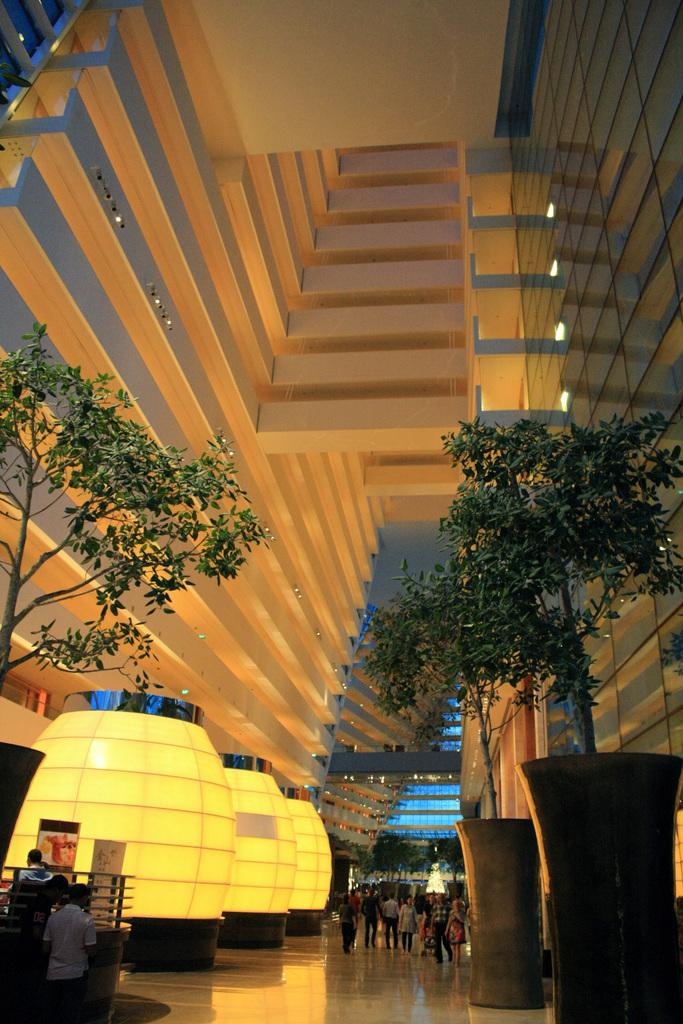What type of location is depicted in the image? The image shows an inside view of a building. Are there any people present in the image? Yes, there are people in the image. What can be seen in the background of the image? There are trees in the image. What additional decorations or features are present in the image? Banners are present in the image. What can be seen illuminating the area in the image? Lights are visible in the image. Can you describe any unspecified objects in the image? There are unspecified objects in the image, but their details are not provided. Where is the lunchroom located in the image? There is no mention of a lunchroom in the image or the provided facts. How many spiders are crawling on the banners in the image? There is no mention of spiders in the image or the provided facts. 